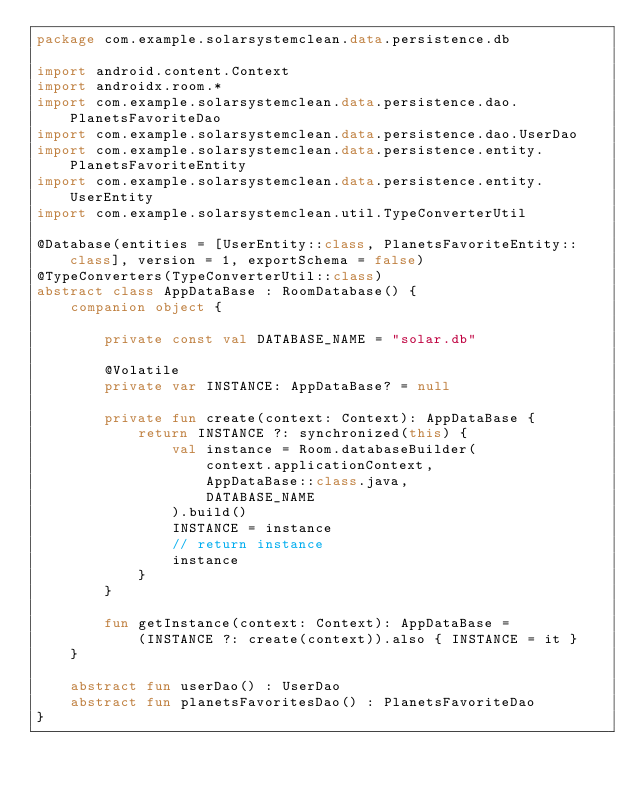Convert code to text. <code><loc_0><loc_0><loc_500><loc_500><_Kotlin_>package com.example.solarsystemclean.data.persistence.db

import android.content.Context
import androidx.room.*
import com.example.solarsystemclean.data.persistence.dao.PlanetsFavoriteDao
import com.example.solarsystemclean.data.persistence.dao.UserDao
import com.example.solarsystemclean.data.persistence.entity.PlanetsFavoriteEntity
import com.example.solarsystemclean.data.persistence.entity.UserEntity
import com.example.solarsystemclean.util.TypeConverterUtil

@Database(entities = [UserEntity::class, PlanetsFavoriteEntity::class], version = 1, exportSchema = false)
@TypeConverters(TypeConverterUtil::class)
abstract class AppDataBase : RoomDatabase() {
    companion object {

        private const val DATABASE_NAME = "solar.db"

        @Volatile
        private var INSTANCE: AppDataBase? = null

        private fun create(context: Context): AppDataBase {
            return INSTANCE ?: synchronized(this) {
                val instance = Room.databaseBuilder(
                    context.applicationContext,
                    AppDataBase::class.java,
                    DATABASE_NAME
                ).build()
                INSTANCE = instance
                // return instance
                instance
            }
        }

        fun getInstance(context: Context): AppDataBase =
            (INSTANCE ?: create(context)).also { INSTANCE = it }
    }

    abstract fun userDao() : UserDao
    abstract fun planetsFavoritesDao() : PlanetsFavoriteDao
}</code> 